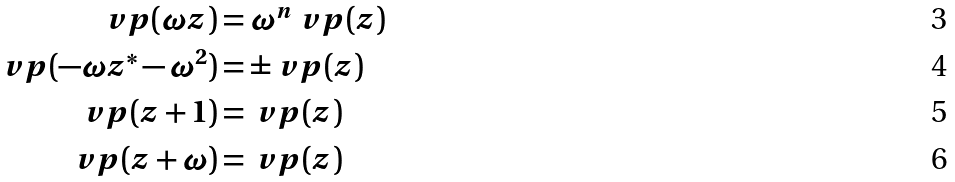<formula> <loc_0><loc_0><loc_500><loc_500>\ v p ( \omega z ) & = \omega ^ { n } \ v p ( z ) \\ \ v p ( - \omega z ^ { * } - \omega ^ { 2 } ) & = \pm \ v p ( z ) \\ \ v p ( z + 1 ) & = \ v p ( z ) \\ \ v p ( z + \omega ) & = \ v p ( z )</formula> 